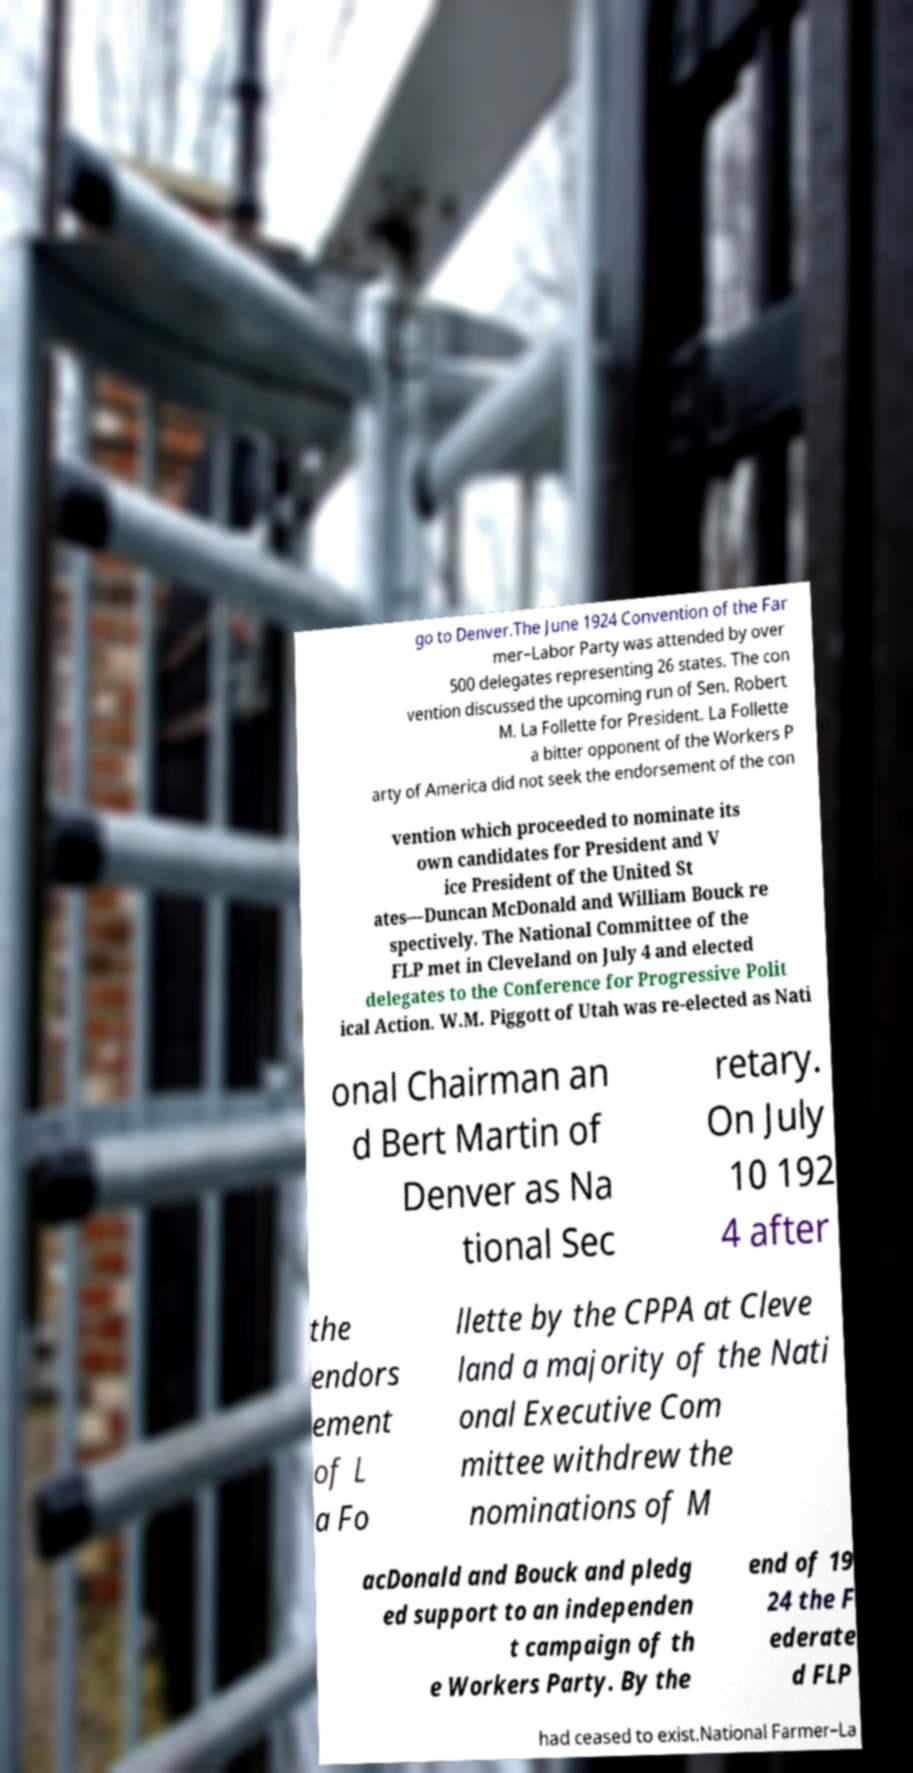I need the written content from this picture converted into text. Can you do that? go to Denver.The June 1924 Convention of the Far mer–Labor Party was attended by over 500 delegates representing 26 states. The con vention discussed the upcoming run of Sen. Robert M. La Follette for President. La Follette a bitter opponent of the Workers P arty of America did not seek the endorsement of the con vention which proceeded to nominate its own candidates for President and V ice President of the United St ates—Duncan McDonald and William Bouck re spectively. The National Committee of the FLP met in Cleveland on July 4 and elected delegates to the Conference for Progressive Polit ical Action. W.M. Piggott of Utah was re-elected as Nati onal Chairman an d Bert Martin of Denver as Na tional Sec retary. On July 10 192 4 after the endors ement of L a Fo llette by the CPPA at Cleve land a majority of the Nati onal Executive Com mittee withdrew the nominations of M acDonald and Bouck and pledg ed support to an independen t campaign of th e Workers Party. By the end of 19 24 the F ederate d FLP had ceased to exist.National Farmer–La 